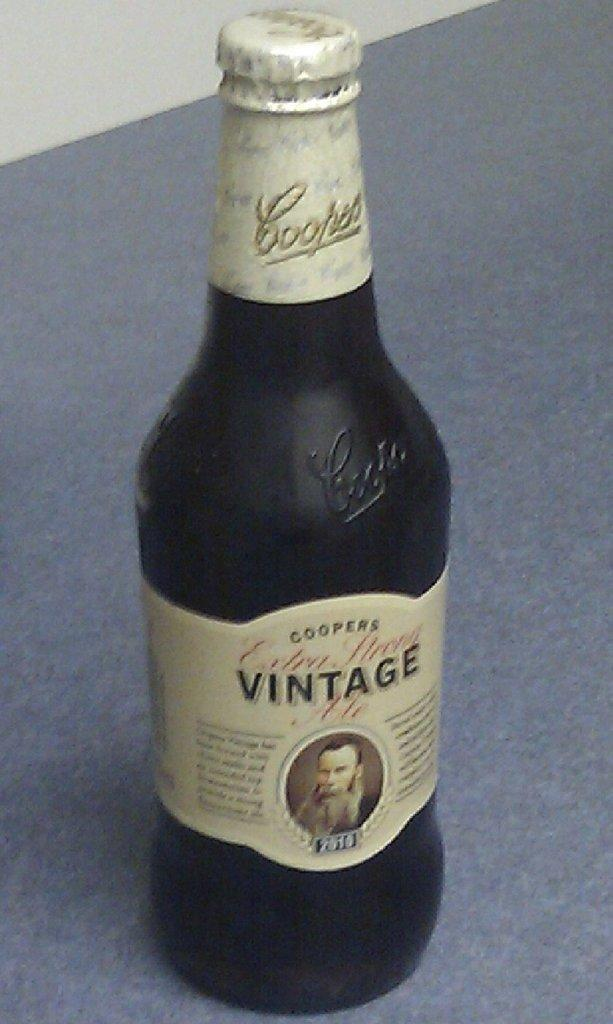<image>
Provide a brief description of the given image. a Vintage bottle with a man's face on it 